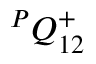<formula> <loc_0><loc_0><loc_500><loc_500>{ } ^ { P } { Q } _ { 1 { 2 } } ^ { + }</formula> 